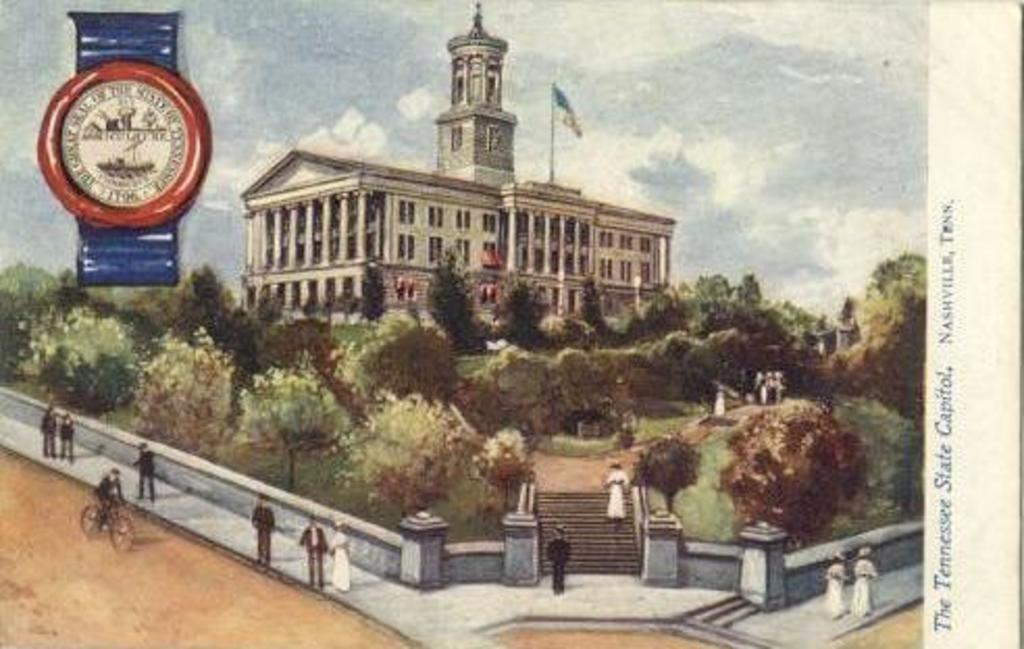Provide a one-sentence caption for the provided image. A painting of a white building at the Tennessee State Capitol. 